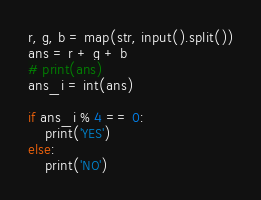<code> <loc_0><loc_0><loc_500><loc_500><_Python_>r, g, b = map(str, input().split())
ans = r + g + b
# print(ans)
ans_i = int(ans)
 
if ans_i % 4 == 0:
    print('YES')
else:
    print('NO')</code> 